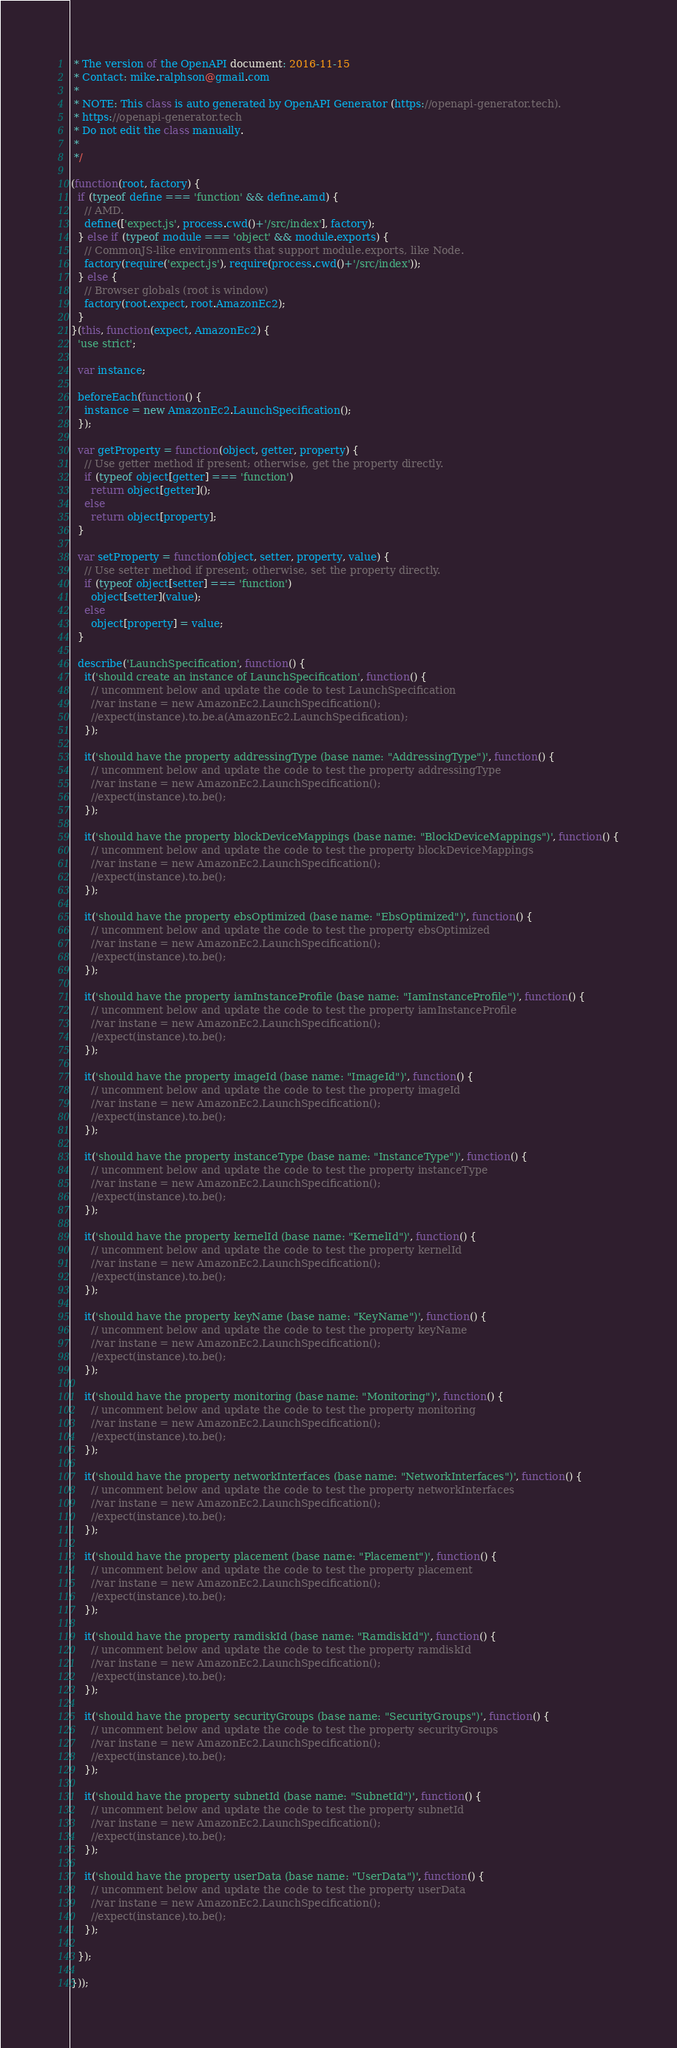Convert code to text. <code><loc_0><loc_0><loc_500><loc_500><_JavaScript_> * The version of the OpenAPI document: 2016-11-15
 * Contact: mike.ralphson@gmail.com
 *
 * NOTE: This class is auto generated by OpenAPI Generator (https://openapi-generator.tech).
 * https://openapi-generator.tech
 * Do not edit the class manually.
 *
 */

(function(root, factory) {
  if (typeof define === 'function' && define.amd) {
    // AMD.
    define(['expect.js', process.cwd()+'/src/index'], factory);
  } else if (typeof module === 'object' && module.exports) {
    // CommonJS-like environments that support module.exports, like Node.
    factory(require('expect.js'), require(process.cwd()+'/src/index'));
  } else {
    // Browser globals (root is window)
    factory(root.expect, root.AmazonEc2);
  }
}(this, function(expect, AmazonEc2) {
  'use strict';

  var instance;

  beforeEach(function() {
    instance = new AmazonEc2.LaunchSpecification();
  });

  var getProperty = function(object, getter, property) {
    // Use getter method if present; otherwise, get the property directly.
    if (typeof object[getter] === 'function')
      return object[getter]();
    else
      return object[property];
  }

  var setProperty = function(object, setter, property, value) {
    // Use setter method if present; otherwise, set the property directly.
    if (typeof object[setter] === 'function')
      object[setter](value);
    else
      object[property] = value;
  }

  describe('LaunchSpecification', function() {
    it('should create an instance of LaunchSpecification', function() {
      // uncomment below and update the code to test LaunchSpecification
      //var instane = new AmazonEc2.LaunchSpecification();
      //expect(instance).to.be.a(AmazonEc2.LaunchSpecification);
    });

    it('should have the property addressingType (base name: "AddressingType")', function() {
      // uncomment below and update the code to test the property addressingType
      //var instane = new AmazonEc2.LaunchSpecification();
      //expect(instance).to.be();
    });

    it('should have the property blockDeviceMappings (base name: "BlockDeviceMappings")', function() {
      // uncomment below and update the code to test the property blockDeviceMappings
      //var instane = new AmazonEc2.LaunchSpecification();
      //expect(instance).to.be();
    });

    it('should have the property ebsOptimized (base name: "EbsOptimized")', function() {
      // uncomment below and update the code to test the property ebsOptimized
      //var instane = new AmazonEc2.LaunchSpecification();
      //expect(instance).to.be();
    });

    it('should have the property iamInstanceProfile (base name: "IamInstanceProfile")', function() {
      // uncomment below and update the code to test the property iamInstanceProfile
      //var instane = new AmazonEc2.LaunchSpecification();
      //expect(instance).to.be();
    });

    it('should have the property imageId (base name: "ImageId")', function() {
      // uncomment below and update the code to test the property imageId
      //var instane = new AmazonEc2.LaunchSpecification();
      //expect(instance).to.be();
    });

    it('should have the property instanceType (base name: "InstanceType")', function() {
      // uncomment below and update the code to test the property instanceType
      //var instane = new AmazonEc2.LaunchSpecification();
      //expect(instance).to.be();
    });

    it('should have the property kernelId (base name: "KernelId")', function() {
      // uncomment below and update the code to test the property kernelId
      //var instane = new AmazonEc2.LaunchSpecification();
      //expect(instance).to.be();
    });

    it('should have the property keyName (base name: "KeyName")', function() {
      // uncomment below and update the code to test the property keyName
      //var instane = new AmazonEc2.LaunchSpecification();
      //expect(instance).to.be();
    });

    it('should have the property monitoring (base name: "Monitoring")', function() {
      // uncomment below and update the code to test the property monitoring
      //var instane = new AmazonEc2.LaunchSpecification();
      //expect(instance).to.be();
    });

    it('should have the property networkInterfaces (base name: "NetworkInterfaces")', function() {
      // uncomment below and update the code to test the property networkInterfaces
      //var instane = new AmazonEc2.LaunchSpecification();
      //expect(instance).to.be();
    });

    it('should have the property placement (base name: "Placement")', function() {
      // uncomment below and update the code to test the property placement
      //var instane = new AmazonEc2.LaunchSpecification();
      //expect(instance).to.be();
    });

    it('should have the property ramdiskId (base name: "RamdiskId")', function() {
      // uncomment below and update the code to test the property ramdiskId
      //var instane = new AmazonEc2.LaunchSpecification();
      //expect(instance).to.be();
    });

    it('should have the property securityGroups (base name: "SecurityGroups")', function() {
      // uncomment below and update the code to test the property securityGroups
      //var instane = new AmazonEc2.LaunchSpecification();
      //expect(instance).to.be();
    });

    it('should have the property subnetId (base name: "SubnetId")', function() {
      // uncomment below and update the code to test the property subnetId
      //var instane = new AmazonEc2.LaunchSpecification();
      //expect(instance).to.be();
    });

    it('should have the property userData (base name: "UserData")', function() {
      // uncomment below and update the code to test the property userData
      //var instane = new AmazonEc2.LaunchSpecification();
      //expect(instance).to.be();
    });

  });

}));
</code> 